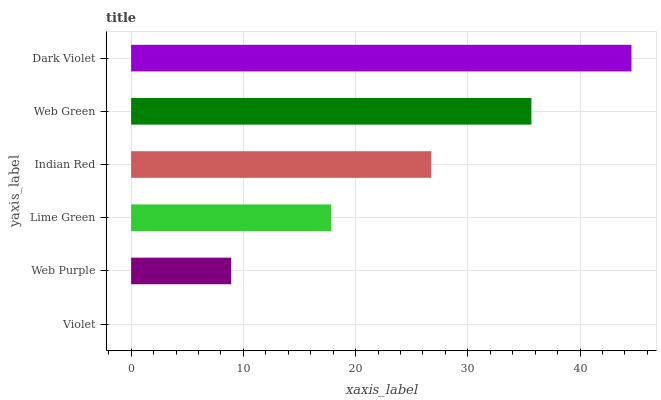Is Violet the minimum?
Answer yes or no. Yes. Is Dark Violet the maximum?
Answer yes or no. Yes. Is Web Purple the minimum?
Answer yes or no. No. Is Web Purple the maximum?
Answer yes or no. No. Is Web Purple greater than Violet?
Answer yes or no. Yes. Is Violet less than Web Purple?
Answer yes or no. Yes. Is Violet greater than Web Purple?
Answer yes or no. No. Is Web Purple less than Violet?
Answer yes or no. No. Is Indian Red the high median?
Answer yes or no. Yes. Is Lime Green the low median?
Answer yes or no. Yes. Is Violet the high median?
Answer yes or no. No. Is Dark Violet the low median?
Answer yes or no. No. 